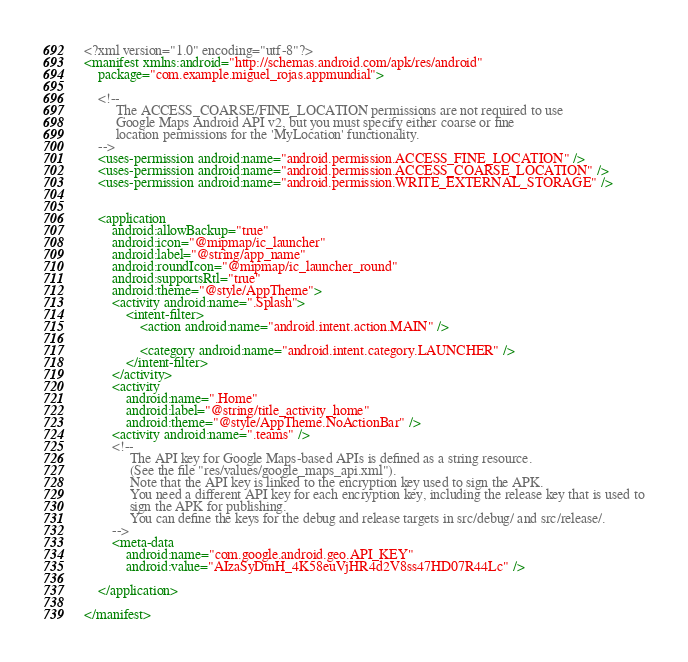<code> <loc_0><loc_0><loc_500><loc_500><_XML_><?xml version="1.0" encoding="utf-8"?>
<manifest xmlns:android="http://schemas.android.com/apk/res/android"
    package="com.example.miguel_rojas.appmundial">

    <!--
         The ACCESS_COARSE/FINE_LOCATION permissions are not required to use
         Google Maps Android API v2, but you must specify either coarse or fine
         location permissions for the 'MyLocation' functionality. 
    -->
    <uses-permission android:name="android.permission.ACCESS_FINE_LOCATION" />
    <uses-permission android:name="android.permission.ACCESS_COARSE_LOCATION" />
    <uses-permission android:name="android.permission.WRITE_EXTERNAL_STORAGE" />


    <application
        android:allowBackup="true"
        android:icon="@mipmap/ic_launcher"
        android:label="@string/app_name"
        android:roundIcon="@mipmap/ic_launcher_round"
        android:supportsRtl="true"
        android:theme="@style/AppTheme">
        <activity android:name=".Splash">
            <intent-filter>
                <action android:name="android.intent.action.MAIN" />

                <category android:name="android.intent.category.LAUNCHER" />
            </intent-filter>
        </activity>
        <activity
            android:name=".Home"
            android:label="@string/title_activity_home"
            android:theme="@style/AppTheme.NoActionBar" />
        <activity android:name=".teams" />
        <!--
             The API key for Google Maps-based APIs is defined as a string resource.
             (See the file "res/values/google_maps_api.xml").
             Note that the API key is linked to the encryption key used to sign the APK.
             You need a different API key for each encryption key, including the release key that is used to
             sign the APK for publishing.
             You can define the keys for the debug and release targets in src/debug/ and src/release/. 
        -->
        <meta-data
            android:name="com.google.android.geo.API_KEY"
            android:value="AIzaSyDtnH_4K58euVjHR4d2V8ss47HD07R44Lc" />

    </application>

</manifest></code> 